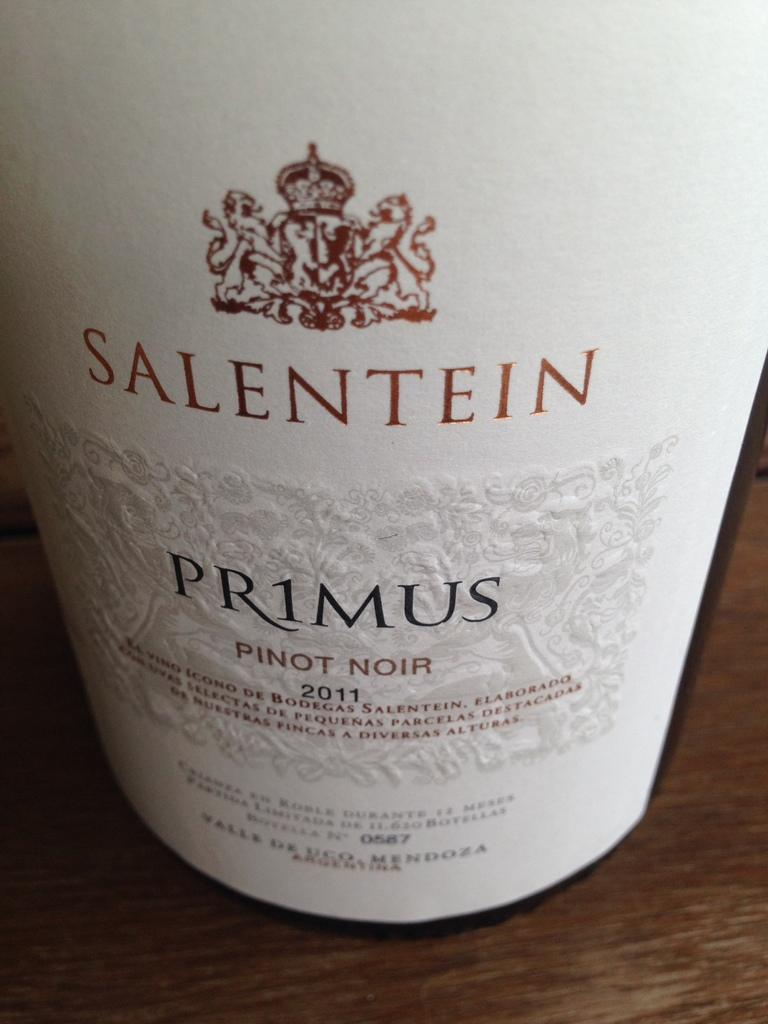Provide a one-sentence caption for the provided image. The bottle of Pinot Noir, from 2011, is white. 